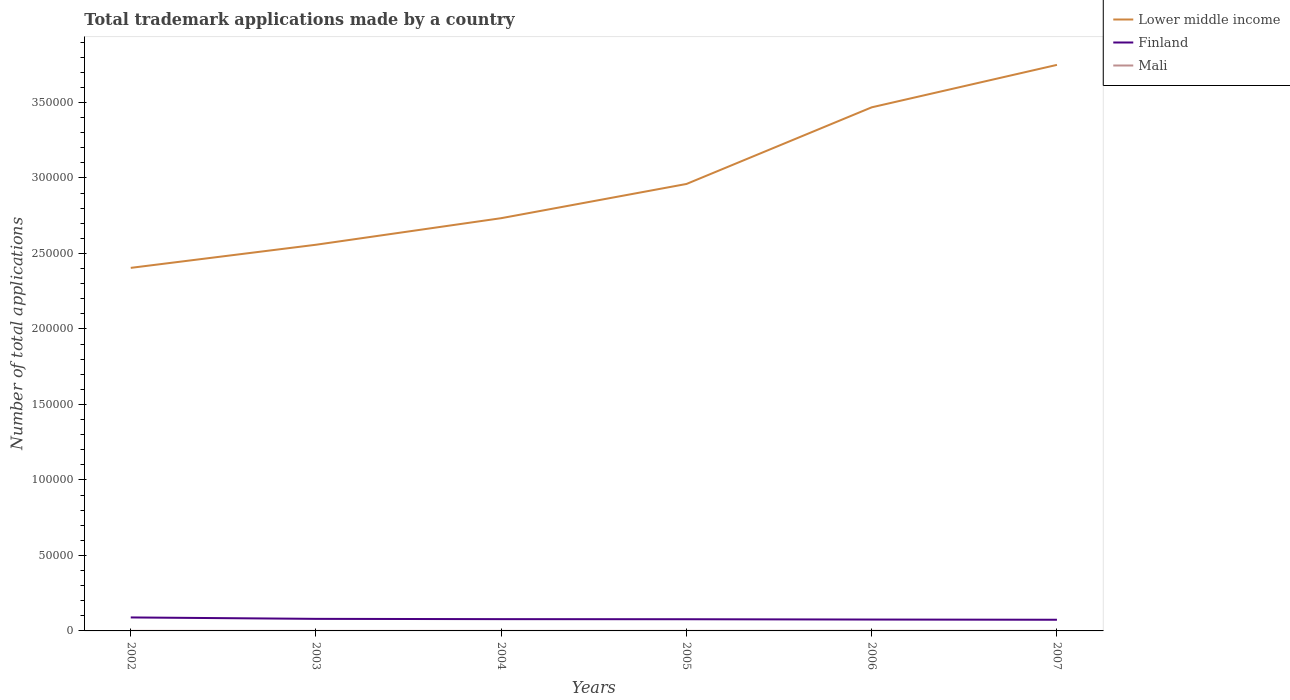How many different coloured lines are there?
Your answer should be very brief. 3. Across all years, what is the maximum number of applications made by in Lower middle income?
Ensure brevity in your answer.  2.40e+05. What is the total number of applications made by in Lower middle income in the graph?
Ensure brevity in your answer.  -2.81e+04. What is the difference between the highest and the second highest number of applications made by in Lower middle income?
Your response must be concise. 1.34e+05. What is the difference between the highest and the lowest number of applications made by in Mali?
Give a very brief answer. 2. Is the number of applications made by in Finland strictly greater than the number of applications made by in Lower middle income over the years?
Ensure brevity in your answer.  Yes. How many years are there in the graph?
Your response must be concise. 6. What is the difference between two consecutive major ticks on the Y-axis?
Make the answer very short. 5.00e+04. Does the graph contain any zero values?
Your answer should be very brief. No. Does the graph contain grids?
Your answer should be compact. No. Where does the legend appear in the graph?
Ensure brevity in your answer.  Top right. How many legend labels are there?
Your answer should be very brief. 3. What is the title of the graph?
Your answer should be compact. Total trademark applications made by a country. Does "Czech Republic" appear as one of the legend labels in the graph?
Your answer should be compact. No. What is the label or title of the X-axis?
Give a very brief answer. Years. What is the label or title of the Y-axis?
Your response must be concise. Number of total applications. What is the Number of total applications in Lower middle income in 2002?
Provide a short and direct response. 2.40e+05. What is the Number of total applications of Finland in 2002?
Make the answer very short. 8934. What is the Number of total applications of Mali in 2002?
Make the answer very short. 29. What is the Number of total applications of Lower middle income in 2003?
Provide a succinct answer. 2.56e+05. What is the Number of total applications of Finland in 2003?
Provide a succinct answer. 7989. What is the Number of total applications in Lower middle income in 2004?
Ensure brevity in your answer.  2.73e+05. What is the Number of total applications of Finland in 2004?
Offer a terse response. 7801. What is the Number of total applications of Lower middle income in 2005?
Your answer should be compact. 2.96e+05. What is the Number of total applications in Finland in 2005?
Offer a very short reply. 7736. What is the Number of total applications of Mali in 2005?
Give a very brief answer. 43. What is the Number of total applications of Lower middle income in 2006?
Your answer should be compact. 3.47e+05. What is the Number of total applications of Finland in 2006?
Offer a terse response. 7533. What is the Number of total applications of Lower middle income in 2007?
Your response must be concise. 3.75e+05. What is the Number of total applications in Finland in 2007?
Ensure brevity in your answer.  7400. Across all years, what is the maximum Number of total applications in Lower middle income?
Offer a very short reply. 3.75e+05. Across all years, what is the maximum Number of total applications in Finland?
Your response must be concise. 8934. Across all years, what is the minimum Number of total applications in Lower middle income?
Your answer should be compact. 2.40e+05. Across all years, what is the minimum Number of total applications of Finland?
Your answer should be very brief. 7400. What is the total Number of total applications in Lower middle income in the graph?
Offer a terse response. 1.79e+06. What is the total Number of total applications of Finland in the graph?
Your answer should be compact. 4.74e+04. What is the total Number of total applications in Mali in the graph?
Offer a terse response. 242. What is the difference between the Number of total applications in Lower middle income in 2002 and that in 2003?
Keep it short and to the point. -1.53e+04. What is the difference between the Number of total applications in Finland in 2002 and that in 2003?
Ensure brevity in your answer.  945. What is the difference between the Number of total applications of Mali in 2002 and that in 2003?
Make the answer very short. 4. What is the difference between the Number of total applications of Lower middle income in 2002 and that in 2004?
Give a very brief answer. -3.29e+04. What is the difference between the Number of total applications of Finland in 2002 and that in 2004?
Your response must be concise. 1133. What is the difference between the Number of total applications in Lower middle income in 2002 and that in 2005?
Ensure brevity in your answer.  -5.56e+04. What is the difference between the Number of total applications of Finland in 2002 and that in 2005?
Keep it short and to the point. 1198. What is the difference between the Number of total applications of Mali in 2002 and that in 2005?
Your response must be concise. -14. What is the difference between the Number of total applications in Lower middle income in 2002 and that in 2006?
Provide a succinct answer. -1.06e+05. What is the difference between the Number of total applications in Finland in 2002 and that in 2006?
Your answer should be very brief. 1401. What is the difference between the Number of total applications of Mali in 2002 and that in 2006?
Offer a terse response. -55. What is the difference between the Number of total applications of Lower middle income in 2002 and that in 2007?
Make the answer very short. -1.34e+05. What is the difference between the Number of total applications in Finland in 2002 and that in 2007?
Ensure brevity in your answer.  1534. What is the difference between the Number of total applications of Lower middle income in 2003 and that in 2004?
Ensure brevity in your answer.  -1.76e+04. What is the difference between the Number of total applications in Finland in 2003 and that in 2004?
Ensure brevity in your answer.  188. What is the difference between the Number of total applications in Mali in 2003 and that in 2004?
Offer a very short reply. -3. What is the difference between the Number of total applications in Lower middle income in 2003 and that in 2005?
Make the answer very short. -4.02e+04. What is the difference between the Number of total applications of Finland in 2003 and that in 2005?
Ensure brevity in your answer.  253. What is the difference between the Number of total applications of Mali in 2003 and that in 2005?
Offer a very short reply. -18. What is the difference between the Number of total applications of Lower middle income in 2003 and that in 2006?
Make the answer very short. -9.10e+04. What is the difference between the Number of total applications of Finland in 2003 and that in 2006?
Make the answer very short. 456. What is the difference between the Number of total applications of Mali in 2003 and that in 2006?
Your answer should be very brief. -59. What is the difference between the Number of total applications in Lower middle income in 2003 and that in 2007?
Provide a short and direct response. -1.19e+05. What is the difference between the Number of total applications in Finland in 2003 and that in 2007?
Make the answer very short. 589. What is the difference between the Number of total applications in Lower middle income in 2004 and that in 2005?
Offer a terse response. -2.26e+04. What is the difference between the Number of total applications of Finland in 2004 and that in 2005?
Offer a terse response. 65. What is the difference between the Number of total applications in Lower middle income in 2004 and that in 2006?
Your response must be concise. -7.34e+04. What is the difference between the Number of total applications in Finland in 2004 and that in 2006?
Give a very brief answer. 268. What is the difference between the Number of total applications of Mali in 2004 and that in 2006?
Provide a short and direct response. -56. What is the difference between the Number of total applications of Lower middle income in 2004 and that in 2007?
Provide a short and direct response. -1.02e+05. What is the difference between the Number of total applications of Finland in 2004 and that in 2007?
Your response must be concise. 401. What is the difference between the Number of total applications of Lower middle income in 2005 and that in 2006?
Give a very brief answer. -5.08e+04. What is the difference between the Number of total applications of Finland in 2005 and that in 2006?
Offer a very short reply. 203. What is the difference between the Number of total applications of Mali in 2005 and that in 2006?
Your response must be concise. -41. What is the difference between the Number of total applications in Lower middle income in 2005 and that in 2007?
Offer a very short reply. -7.89e+04. What is the difference between the Number of total applications in Finland in 2005 and that in 2007?
Give a very brief answer. 336. What is the difference between the Number of total applications of Lower middle income in 2006 and that in 2007?
Offer a terse response. -2.81e+04. What is the difference between the Number of total applications in Finland in 2006 and that in 2007?
Ensure brevity in your answer.  133. What is the difference between the Number of total applications in Mali in 2006 and that in 2007?
Ensure brevity in your answer.  51. What is the difference between the Number of total applications of Lower middle income in 2002 and the Number of total applications of Finland in 2003?
Provide a succinct answer. 2.32e+05. What is the difference between the Number of total applications of Lower middle income in 2002 and the Number of total applications of Mali in 2003?
Keep it short and to the point. 2.40e+05. What is the difference between the Number of total applications in Finland in 2002 and the Number of total applications in Mali in 2003?
Your response must be concise. 8909. What is the difference between the Number of total applications of Lower middle income in 2002 and the Number of total applications of Finland in 2004?
Offer a very short reply. 2.33e+05. What is the difference between the Number of total applications in Lower middle income in 2002 and the Number of total applications in Mali in 2004?
Ensure brevity in your answer.  2.40e+05. What is the difference between the Number of total applications in Finland in 2002 and the Number of total applications in Mali in 2004?
Provide a succinct answer. 8906. What is the difference between the Number of total applications in Lower middle income in 2002 and the Number of total applications in Finland in 2005?
Provide a succinct answer. 2.33e+05. What is the difference between the Number of total applications of Lower middle income in 2002 and the Number of total applications of Mali in 2005?
Give a very brief answer. 2.40e+05. What is the difference between the Number of total applications of Finland in 2002 and the Number of total applications of Mali in 2005?
Provide a short and direct response. 8891. What is the difference between the Number of total applications in Lower middle income in 2002 and the Number of total applications in Finland in 2006?
Your answer should be very brief. 2.33e+05. What is the difference between the Number of total applications in Lower middle income in 2002 and the Number of total applications in Mali in 2006?
Your answer should be very brief. 2.40e+05. What is the difference between the Number of total applications in Finland in 2002 and the Number of total applications in Mali in 2006?
Your answer should be compact. 8850. What is the difference between the Number of total applications of Lower middle income in 2002 and the Number of total applications of Finland in 2007?
Your response must be concise. 2.33e+05. What is the difference between the Number of total applications of Lower middle income in 2002 and the Number of total applications of Mali in 2007?
Offer a very short reply. 2.40e+05. What is the difference between the Number of total applications of Finland in 2002 and the Number of total applications of Mali in 2007?
Your answer should be very brief. 8901. What is the difference between the Number of total applications of Lower middle income in 2003 and the Number of total applications of Finland in 2004?
Your response must be concise. 2.48e+05. What is the difference between the Number of total applications of Lower middle income in 2003 and the Number of total applications of Mali in 2004?
Your answer should be compact. 2.56e+05. What is the difference between the Number of total applications in Finland in 2003 and the Number of total applications in Mali in 2004?
Offer a very short reply. 7961. What is the difference between the Number of total applications of Lower middle income in 2003 and the Number of total applications of Finland in 2005?
Keep it short and to the point. 2.48e+05. What is the difference between the Number of total applications in Lower middle income in 2003 and the Number of total applications in Mali in 2005?
Give a very brief answer. 2.56e+05. What is the difference between the Number of total applications in Finland in 2003 and the Number of total applications in Mali in 2005?
Your answer should be very brief. 7946. What is the difference between the Number of total applications of Lower middle income in 2003 and the Number of total applications of Finland in 2006?
Offer a terse response. 2.48e+05. What is the difference between the Number of total applications of Lower middle income in 2003 and the Number of total applications of Mali in 2006?
Offer a terse response. 2.56e+05. What is the difference between the Number of total applications in Finland in 2003 and the Number of total applications in Mali in 2006?
Provide a succinct answer. 7905. What is the difference between the Number of total applications in Lower middle income in 2003 and the Number of total applications in Finland in 2007?
Offer a terse response. 2.48e+05. What is the difference between the Number of total applications in Lower middle income in 2003 and the Number of total applications in Mali in 2007?
Keep it short and to the point. 2.56e+05. What is the difference between the Number of total applications in Finland in 2003 and the Number of total applications in Mali in 2007?
Give a very brief answer. 7956. What is the difference between the Number of total applications of Lower middle income in 2004 and the Number of total applications of Finland in 2005?
Provide a succinct answer. 2.66e+05. What is the difference between the Number of total applications in Lower middle income in 2004 and the Number of total applications in Mali in 2005?
Your answer should be very brief. 2.73e+05. What is the difference between the Number of total applications of Finland in 2004 and the Number of total applications of Mali in 2005?
Make the answer very short. 7758. What is the difference between the Number of total applications of Lower middle income in 2004 and the Number of total applications of Finland in 2006?
Give a very brief answer. 2.66e+05. What is the difference between the Number of total applications in Lower middle income in 2004 and the Number of total applications in Mali in 2006?
Provide a short and direct response. 2.73e+05. What is the difference between the Number of total applications in Finland in 2004 and the Number of total applications in Mali in 2006?
Keep it short and to the point. 7717. What is the difference between the Number of total applications of Lower middle income in 2004 and the Number of total applications of Finland in 2007?
Your answer should be very brief. 2.66e+05. What is the difference between the Number of total applications in Lower middle income in 2004 and the Number of total applications in Mali in 2007?
Your answer should be very brief. 2.73e+05. What is the difference between the Number of total applications of Finland in 2004 and the Number of total applications of Mali in 2007?
Your response must be concise. 7768. What is the difference between the Number of total applications in Lower middle income in 2005 and the Number of total applications in Finland in 2006?
Provide a short and direct response. 2.88e+05. What is the difference between the Number of total applications of Lower middle income in 2005 and the Number of total applications of Mali in 2006?
Keep it short and to the point. 2.96e+05. What is the difference between the Number of total applications of Finland in 2005 and the Number of total applications of Mali in 2006?
Offer a very short reply. 7652. What is the difference between the Number of total applications of Lower middle income in 2005 and the Number of total applications of Finland in 2007?
Make the answer very short. 2.89e+05. What is the difference between the Number of total applications in Lower middle income in 2005 and the Number of total applications in Mali in 2007?
Provide a succinct answer. 2.96e+05. What is the difference between the Number of total applications of Finland in 2005 and the Number of total applications of Mali in 2007?
Your answer should be compact. 7703. What is the difference between the Number of total applications of Lower middle income in 2006 and the Number of total applications of Finland in 2007?
Offer a very short reply. 3.39e+05. What is the difference between the Number of total applications in Lower middle income in 2006 and the Number of total applications in Mali in 2007?
Make the answer very short. 3.47e+05. What is the difference between the Number of total applications of Finland in 2006 and the Number of total applications of Mali in 2007?
Your response must be concise. 7500. What is the average Number of total applications in Lower middle income per year?
Make the answer very short. 2.98e+05. What is the average Number of total applications of Finland per year?
Your response must be concise. 7898.83. What is the average Number of total applications of Mali per year?
Offer a very short reply. 40.33. In the year 2002, what is the difference between the Number of total applications of Lower middle income and Number of total applications of Finland?
Keep it short and to the point. 2.32e+05. In the year 2002, what is the difference between the Number of total applications in Lower middle income and Number of total applications in Mali?
Keep it short and to the point. 2.40e+05. In the year 2002, what is the difference between the Number of total applications of Finland and Number of total applications of Mali?
Make the answer very short. 8905. In the year 2003, what is the difference between the Number of total applications of Lower middle income and Number of total applications of Finland?
Offer a very short reply. 2.48e+05. In the year 2003, what is the difference between the Number of total applications of Lower middle income and Number of total applications of Mali?
Provide a short and direct response. 2.56e+05. In the year 2003, what is the difference between the Number of total applications in Finland and Number of total applications in Mali?
Keep it short and to the point. 7964. In the year 2004, what is the difference between the Number of total applications in Lower middle income and Number of total applications in Finland?
Make the answer very short. 2.66e+05. In the year 2004, what is the difference between the Number of total applications in Lower middle income and Number of total applications in Mali?
Provide a succinct answer. 2.73e+05. In the year 2004, what is the difference between the Number of total applications of Finland and Number of total applications of Mali?
Offer a very short reply. 7773. In the year 2005, what is the difference between the Number of total applications of Lower middle income and Number of total applications of Finland?
Your response must be concise. 2.88e+05. In the year 2005, what is the difference between the Number of total applications in Lower middle income and Number of total applications in Mali?
Offer a terse response. 2.96e+05. In the year 2005, what is the difference between the Number of total applications in Finland and Number of total applications in Mali?
Keep it short and to the point. 7693. In the year 2006, what is the difference between the Number of total applications in Lower middle income and Number of total applications in Finland?
Your answer should be very brief. 3.39e+05. In the year 2006, what is the difference between the Number of total applications of Lower middle income and Number of total applications of Mali?
Provide a short and direct response. 3.47e+05. In the year 2006, what is the difference between the Number of total applications in Finland and Number of total applications in Mali?
Your answer should be compact. 7449. In the year 2007, what is the difference between the Number of total applications of Lower middle income and Number of total applications of Finland?
Offer a terse response. 3.67e+05. In the year 2007, what is the difference between the Number of total applications in Lower middle income and Number of total applications in Mali?
Offer a terse response. 3.75e+05. In the year 2007, what is the difference between the Number of total applications in Finland and Number of total applications in Mali?
Keep it short and to the point. 7367. What is the ratio of the Number of total applications in Lower middle income in 2002 to that in 2003?
Provide a succinct answer. 0.94. What is the ratio of the Number of total applications in Finland in 2002 to that in 2003?
Your answer should be very brief. 1.12. What is the ratio of the Number of total applications in Mali in 2002 to that in 2003?
Your response must be concise. 1.16. What is the ratio of the Number of total applications of Lower middle income in 2002 to that in 2004?
Keep it short and to the point. 0.88. What is the ratio of the Number of total applications in Finland in 2002 to that in 2004?
Your answer should be compact. 1.15. What is the ratio of the Number of total applications in Mali in 2002 to that in 2004?
Provide a short and direct response. 1.04. What is the ratio of the Number of total applications of Lower middle income in 2002 to that in 2005?
Your answer should be compact. 0.81. What is the ratio of the Number of total applications in Finland in 2002 to that in 2005?
Provide a succinct answer. 1.15. What is the ratio of the Number of total applications in Mali in 2002 to that in 2005?
Provide a succinct answer. 0.67. What is the ratio of the Number of total applications in Lower middle income in 2002 to that in 2006?
Your response must be concise. 0.69. What is the ratio of the Number of total applications in Finland in 2002 to that in 2006?
Your answer should be compact. 1.19. What is the ratio of the Number of total applications of Mali in 2002 to that in 2006?
Give a very brief answer. 0.35. What is the ratio of the Number of total applications in Lower middle income in 2002 to that in 2007?
Offer a terse response. 0.64. What is the ratio of the Number of total applications in Finland in 2002 to that in 2007?
Provide a succinct answer. 1.21. What is the ratio of the Number of total applications in Mali in 2002 to that in 2007?
Offer a very short reply. 0.88. What is the ratio of the Number of total applications in Lower middle income in 2003 to that in 2004?
Make the answer very short. 0.94. What is the ratio of the Number of total applications of Finland in 2003 to that in 2004?
Your answer should be very brief. 1.02. What is the ratio of the Number of total applications in Mali in 2003 to that in 2004?
Offer a very short reply. 0.89. What is the ratio of the Number of total applications in Lower middle income in 2003 to that in 2005?
Keep it short and to the point. 0.86. What is the ratio of the Number of total applications in Finland in 2003 to that in 2005?
Offer a terse response. 1.03. What is the ratio of the Number of total applications of Mali in 2003 to that in 2005?
Ensure brevity in your answer.  0.58. What is the ratio of the Number of total applications of Lower middle income in 2003 to that in 2006?
Ensure brevity in your answer.  0.74. What is the ratio of the Number of total applications in Finland in 2003 to that in 2006?
Offer a very short reply. 1.06. What is the ratio of the Number of total applications of Mali in 2003 to that in 2006?
Make the answer very short. 0.3. What is the ratio of the Number of total applications in Lower middle income in 2003 to that in 2007?
Offer a terse response. 0.68. What is the ratio of the Number of total applications of Finland in 2003 to that in 2007?
Provide a short and direct response. 1.08. What is the ratio of the Number of total applications of Mali in 2003 to that in 2007?
Provide a succinct answer. 0.76. What is the ratio of the Number of total applications of Lower middle income in 2004 to that in 2005?
Give a very brief answer. 0.92. What is the ratio of the Number of total applications of Finland in 2004 to that in 2005?
Ensure brevity in your answer.  1.01. What is the ratio of the Number of total applications of Mali in 2004 to that in 2005?
Provide a short and direct response. 0.65. What is the ratio of the Number of total applications of Lower middle income in 2004 to that in 2006?
Offer a very short reply. 0.79. What is the ratio of the Number of total applications of Finland in 2004 to that in 2006?
Your answer should be very brief. 1.04. What is the ratio of the Number of total applications of Lower middle income in 2004 to that in 2007?
Ensure brevity in your answer.  0.73. What is the ratio of the Number of total applications of Finland in 2004 to that in 2007?
Offer a very short reply. 1.05. What is the ratio of the Number of total applications of Mali in 2004 to that in 2007?
Make the answer very short. 0.85. What is the ratio of the Number of total applications of Lower middle income in 2005 to that in 2006?
Give a very brief answer. 0.85. What is the ratio of the Number of total applications in Finland in 2005 to that in 2006?
Provide a short and direct response. 1.03. What is the ratio of the Number of total applications of Mali in 2005 to that in 2006?
Provide a succinct answer. 0.51. What is the ratio of the Number of total applications in Lower middle income in 2005 to that in 2007?
Give a very brief answer. 0.79. What is the ratio of the Number of total applications of Finland in 2005 to that in 2007?
Provide a succinct answer. 1.05. What is the ratio of the Number of total applications in Mali in 2005 to that in 2007?
Make the answer very short. 1.3. What is the ratio of the Number of total applications of Lower middle income in 2006 to that in 2007?
Give a very brief answer. 0.93. What is the ratio of the Number of total applications in Finland in 2006 to that in 2007?
Provide a succinct answer. 1.02. What is the ratio of the Number of total applications of Mali in 2006 to that in 2007?
Offer a very short reply. 2.55. What is the difference between the highest and the second highest Number of total applications of Lower middle income?
Make the answer very short. 2.81e+04. What is the difference between the highest and the second highest Number of total applications in Finland?
Your answer should be very brief. 945. What is the difference between the highest and the second highest Number of total applications of Mali?
Ensure brevity in your answer.  41. What is the difference between the highest and the lowest Number of total applications in Lower middle income?
Offer a very short reply. 1.34e+05. What is the difference between the highest and the lowest Number of total applications in Finland?
Your answer should be compact. 1534. What is the difference between the highest and the lowest Number of total applications in Mali?
Offer a very short reply. 59. 